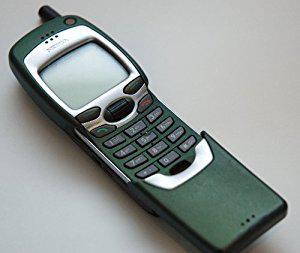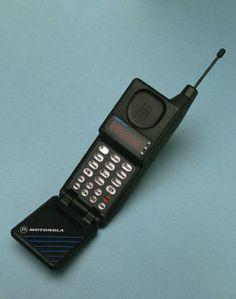The first image is the image on the left, the second image is the image on the right. For the images shown, is this caption "Both phones are pointing to the right." true? Answer yes or no. No. 